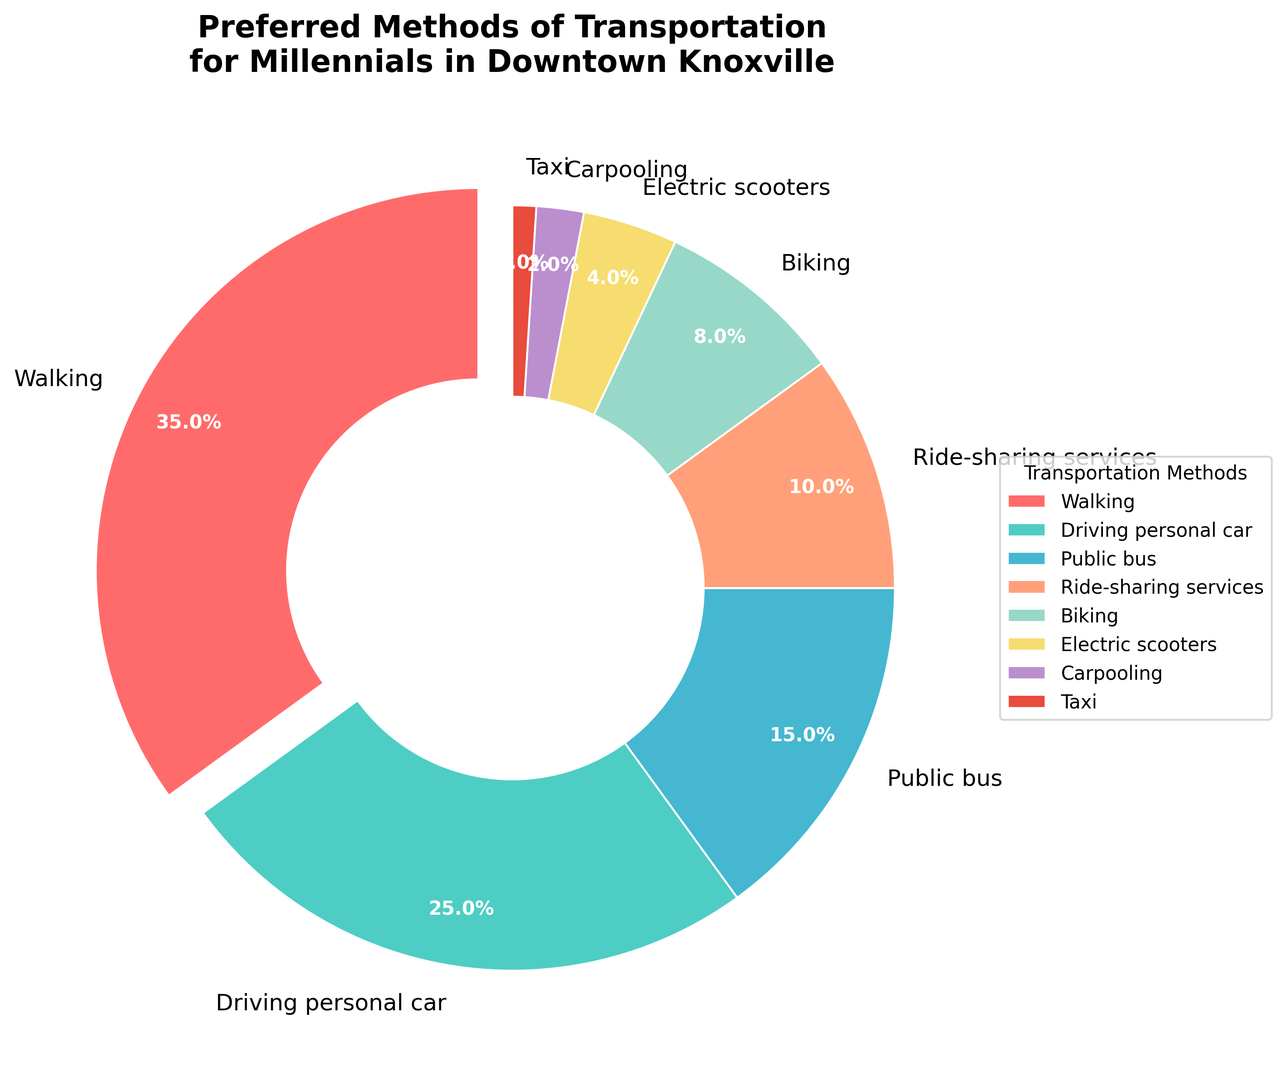What's the most preferred method of transportation among millennials in downtown Knoxville? By looking at the pie chart, we can see that "Walking" has the largest slice, indicating it is the most preferred method of transportation.
Answer: Walking Which method has a higher preference, biking or ride-sharing services? We compare the slices of "Biking" and "Ride-sharing services" by their percentages. "Ride-sharing services" has 10% while "Biking" has 8%, meaning ride-sharing is preferred more.
Answer: Ride-sharing services What percentage of millennials prefer driving their personal car? By examining the pie chart section labeled "Driving personal car," we see that it represents 25% of the total.
Answer: 25% What is the combined percentage of people using electric scooters and taxis? We look at the segments for "Electric scooters" and "Taxi." Adding up their percentages, 4% + 1% = 5%.
Answer: 5% Are public buses more popular than biking? We compare the slices of "Public bus" and "Biking." The "Public bus" slice is labeled 15%, whereas the "Biking" slice is 8%, indicating that public buses are more popular.
Answer: Yes What is the least preferred method of transportation? Observing the pie chart, the smallest slice labeled "Taxi" represents the least preferred method with 1%.
Answer: Taxi How many methods have a preference of less than 10%? We identify the slices with percentages less than 10%: "Biking" (8%), "Electric scooters" (4%), "Carpooling" (2%), and "Taxi" (1%). Counting these, there are 4 methods.
Answer: 4 What's the difference in preference percentage between walking and driving a personal car? We look at the slices for "Walking" (35%) and "Driving personal car" (25%) and calculate the difference: 35% - 25% = 10%.
Answer: 10% Which method is represented by the yellowish color in the chart? Observing the color-coding of the pie chart, the yellowish color corresponds to "Electric Scooters."
Answer: Electric scooters What is the cumulative percentage for methods that use a vehicle (driving personal car, ride-sharing services, taxi, carpooling)? Adding the percentages for "Driving personal car" (25%), "Ride-sharing services" (10%), "Taxi" (1%), and "Carpooling" (2%), we get 25% + 10% + 1% + 2% = 38%.
Answer: 38% 